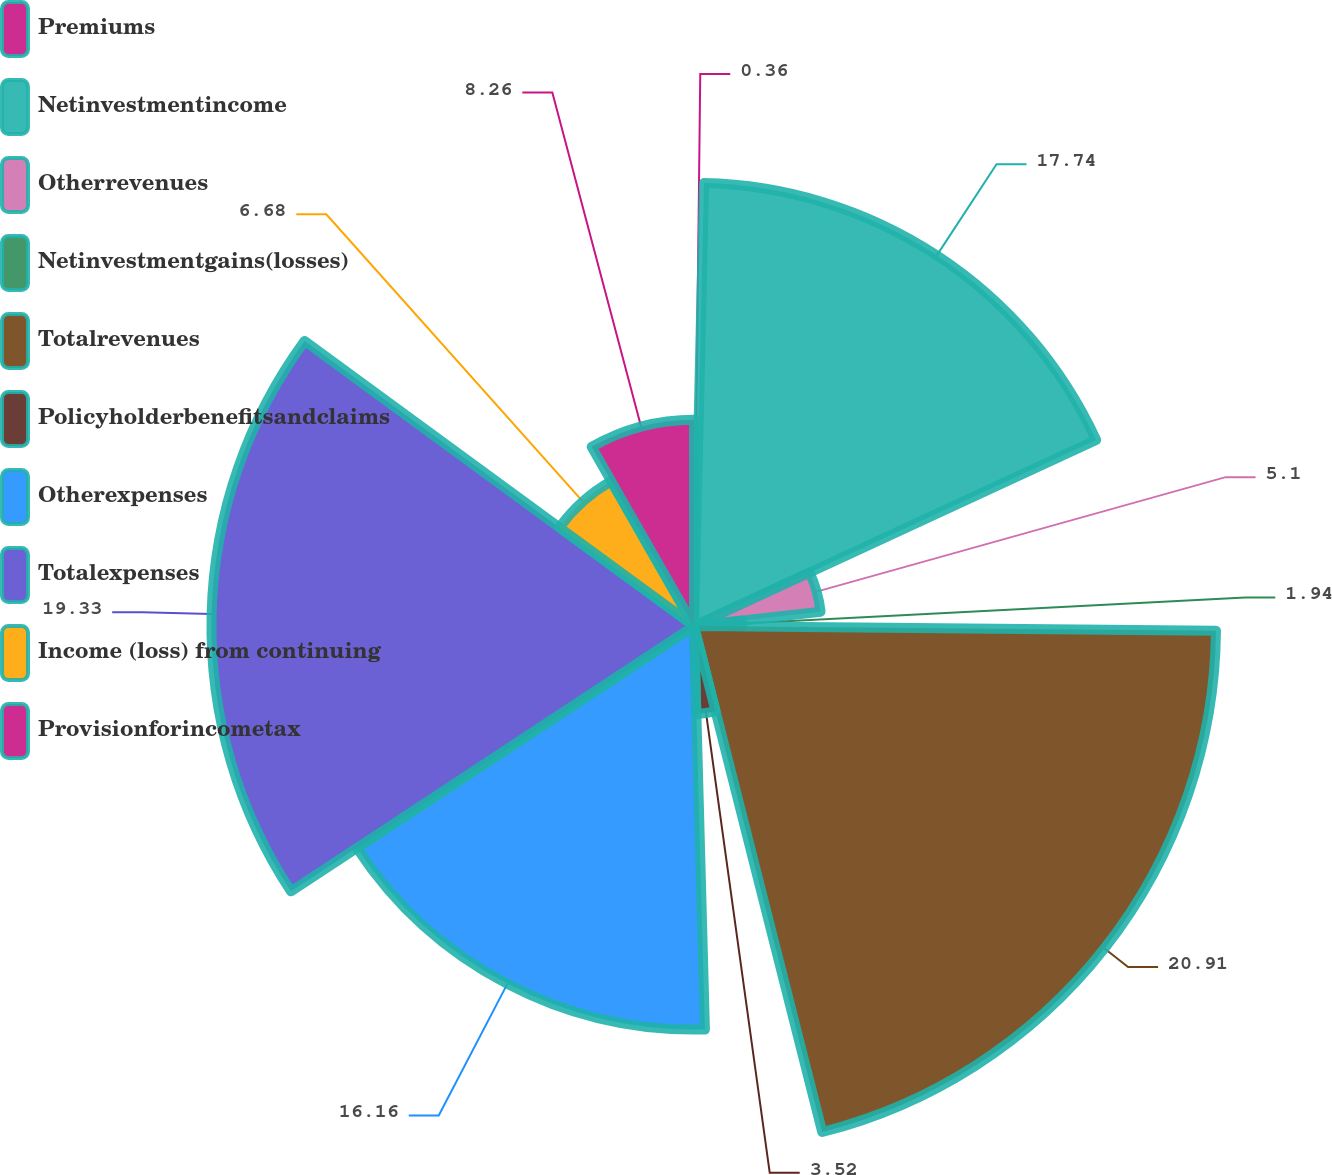Convert chart to OTSL. <chart><loc_0><loc_0><loc_500><loc_500><pie_chart><fcel>Premiums<fcel>Netinvestmentincome<fcel>Otherrevenues<fcel>Netinvestmentgains(losses)<fcel>Totalrevenues<fcel>Policyholderbenefitsandclaims<fcel>Otherexpenses<fcel>Totalexpenses<fcel>Income (loss) from continuing<fcel>Provisionforincometax<nl><fcel>0.36%<fcel>17.74%<fcel>5.1%<fcel>1.94%<fcel>20.9%<fcel>3.52%<fcel>16.16%<fcel>19.32%<fcel>6.68%<fcel>8.26%<nl></chart> 